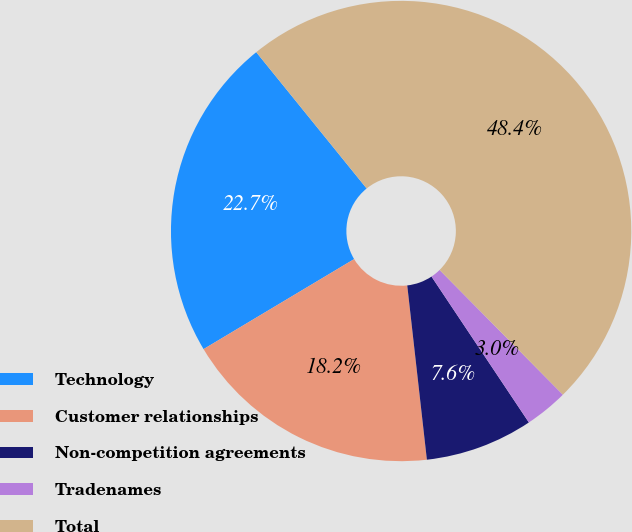<chart> <loc_0><loc_0><loc_500><loc_500><pie_chart><fcel>Technology<fcel>Customer relationships<fcel>Non-competition agreements<fcel>Tradenames<fcel>Total<nl><fcel>22.74%<fcel>18.21%<fcel>7.58%<fcel>3.04%<fcel>48.43%<nl></chart> 